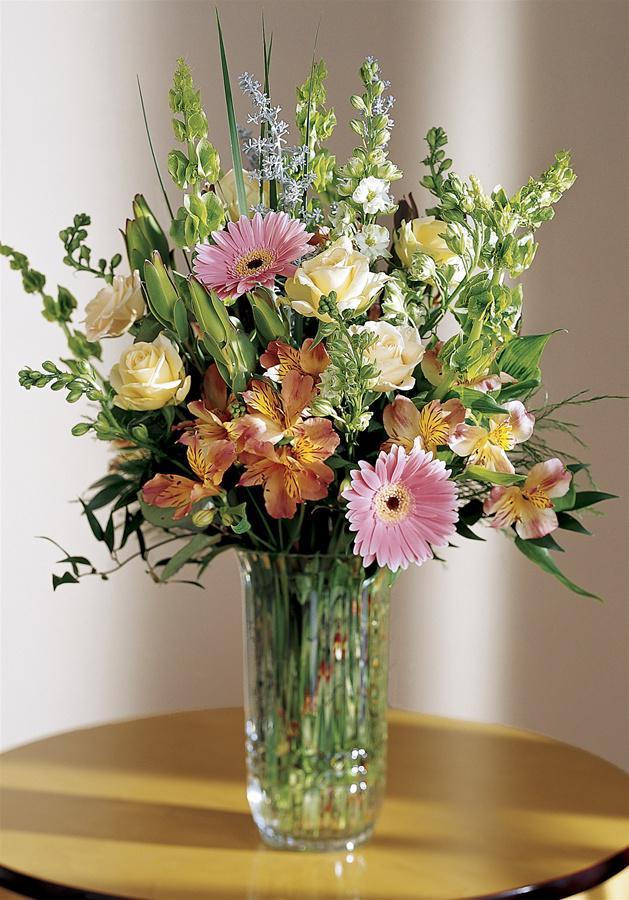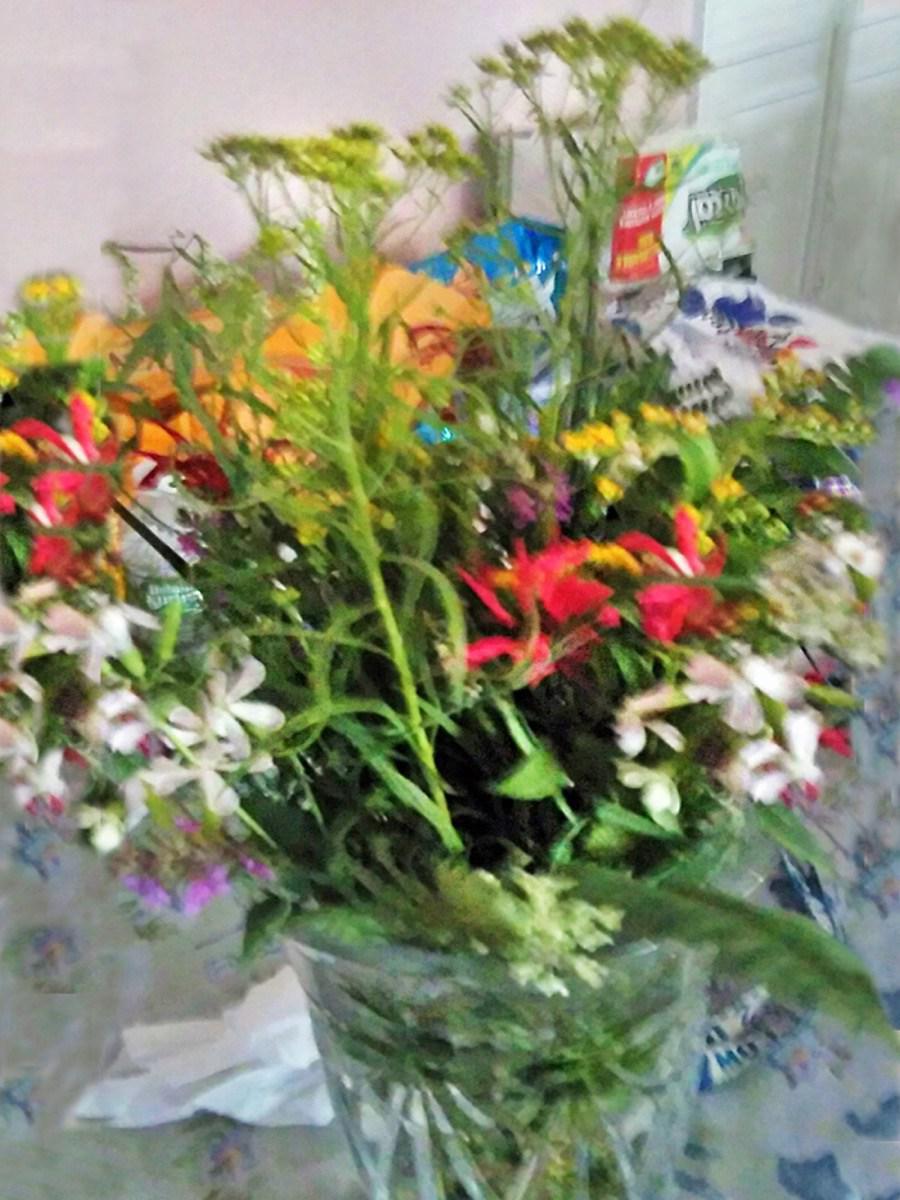The first image is the image on the left, the second image is the image on the right. Given the left and right images, does the statement "One image features a single floral arrangement, which includes long stems with yellow flowers in an opaque container with at least one handle." hold true? Answer yes or no. No. The first image is the image on the left, the second image is the image on the right. Considering the images on both sides, is "In one of the images there is at least one bouquet in a clear glass vase." valid? Answer yes or no. Yes. 